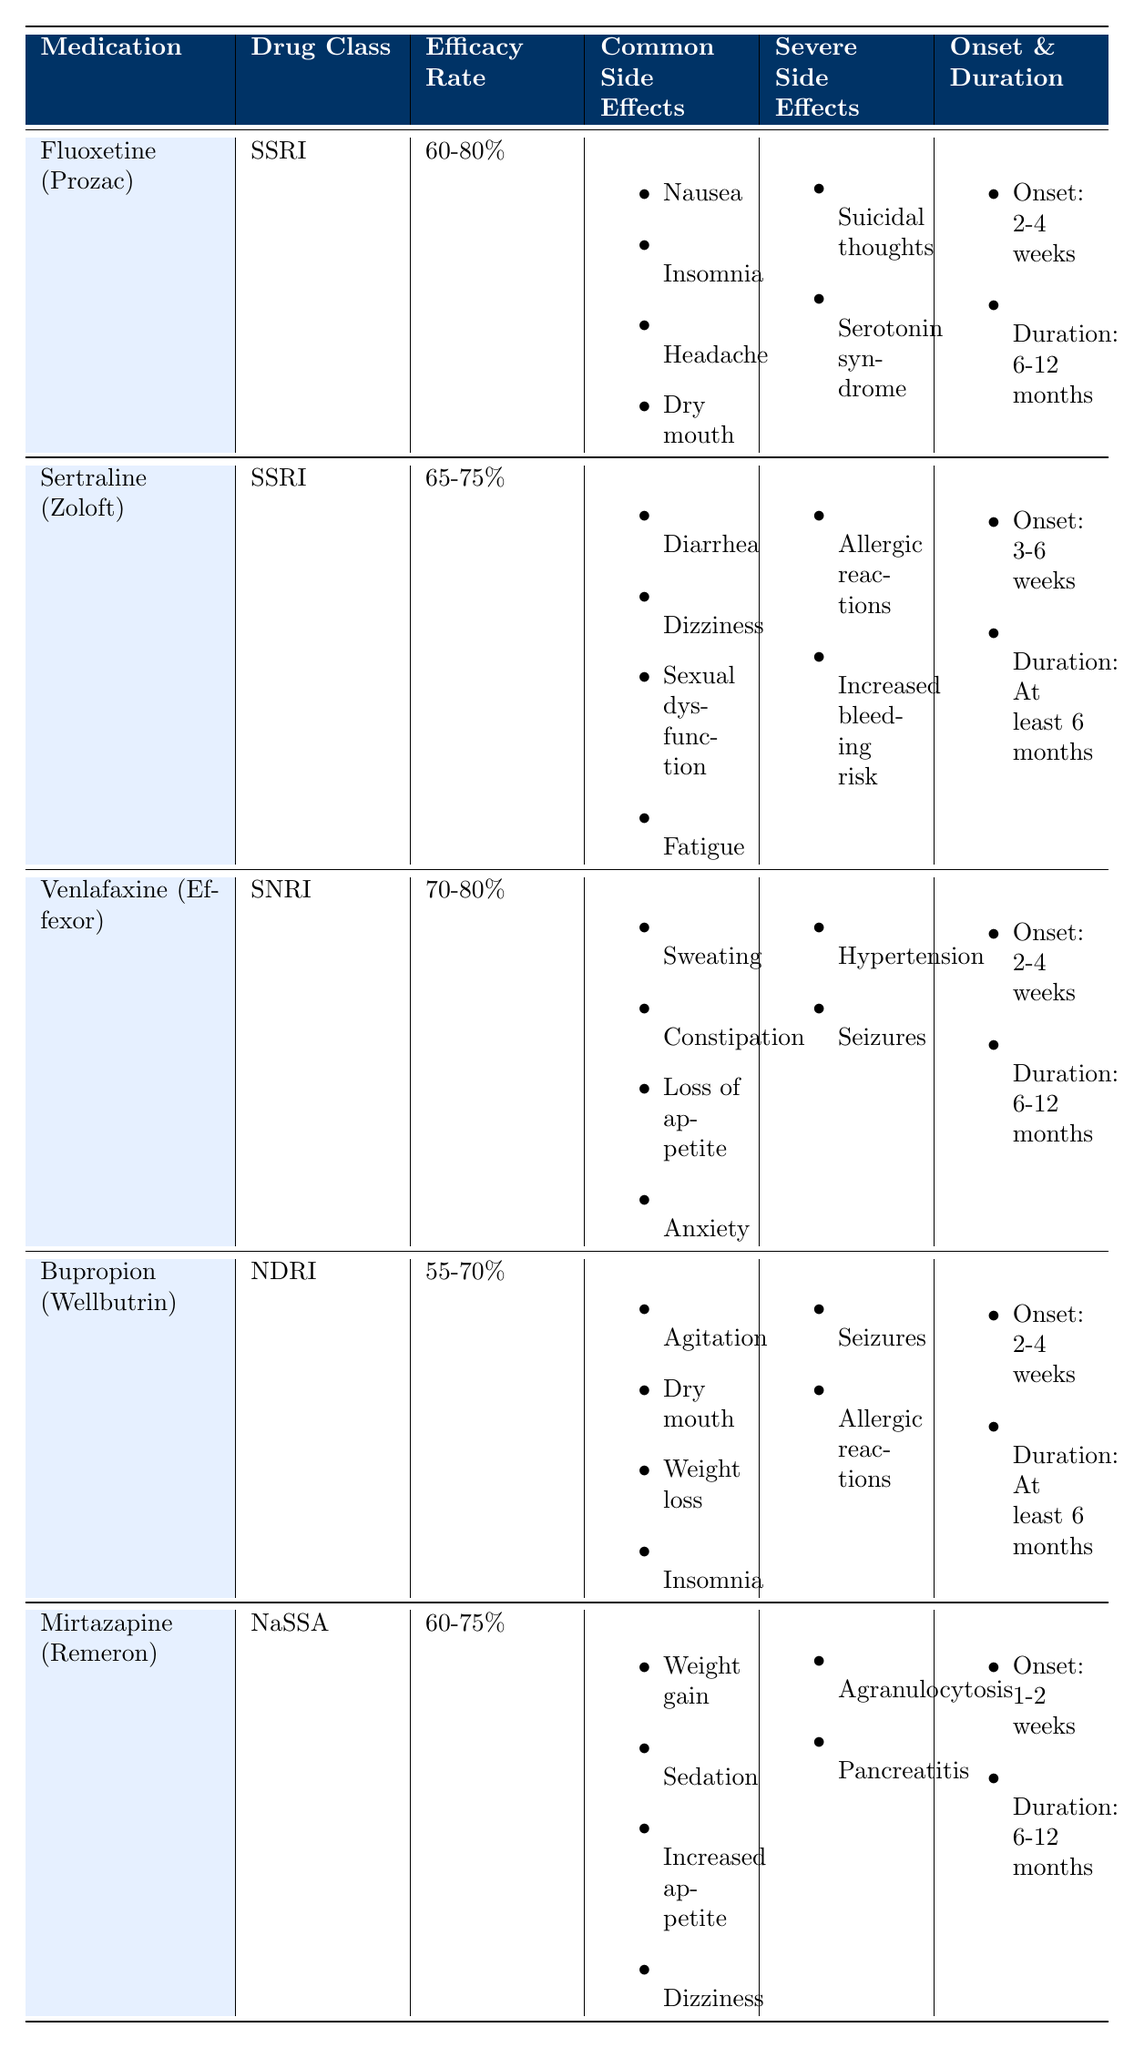What is the efficacy rate of Bupropion (Wellbutrin)? Bupropion (Wellbutrin) has an efficacy rate of 55-70%, which can be directly found in the efficacy rate column for this medication in the table.
Answer: 55-70% Which antidepressant has the highest reported efficacy rate? Venlafaxine (Effexor) and Fluoxetine (Prozac) have the highest efficacy rates of 70-80% and 60-80%, respectively. However, the highest value in this range is 80%, belonging to Venlafaxine.
Answer: Venlafaxine (Effexor) True or False: Sertraline (Zoloft) has severe side effects of hypertension and seizures. The severe side effects listed for Sertraline (Zoloft) are allergic reactions and increased bleeding risk. Hypertension and seizures are severe side effects for Venlafaxine (Effexor). Therefore, the statement is false.
Answer: False What is the common side effect shared by both Fluoxetine (Prozac) and Bupropion (Wellbutrin)? Both Fluoxetine and Bupropion feature dry mouth as a common side effect. This can be confirmed by checking the common side effects list for each medication in the table.
Answer: Dry mouth Which drug class does Mirtazapine (Remeron) belong to, and what is its onset of action? Mirtazapine (Remeron) belongs to the NaSSA drug class, and its onset of action is between 1-2 weeks. This information can be found under the respective columns in the table.
Answer: NaSSA; 1-2 weeks What is the average efficacy rate of the two SSRIs listed, Fluoxetine (Prozac) and Sertraline (Zoloft)? Fluoxetine has an efficacy rate of 60-80%, and Sertraline has an efficacy rate of 65-75%. To calculate the average, we can take the average of the lower values (60 and 65) which is (60+65)/2 = 62.5; then average the higher values (80 and 75), which gives (80+75)/2 = 77.5. Hence, the average efficacy rate of these two antidepressants ranges from 62.5% to 77.5%.
Answer: 62.5%-77.5% What are the severe side effects associated with Venlafaxine (Effexor)? The severe side effects for Venlafaxine (Effexor) are listed as hypertension and seizures. This information is available directly in the severe side effects column.
Answer: Hypertension, seizures Identify the medications with a recommended duration of at least six months. Both Bupropion (Wellbutrin) and Sertraline (Zoloft) have a recommended duration of at least six months. Checking the duration column for both medications confirms this information.
Answer: Bupropion (Wellbutrin), Sertraline (Zoloft) 